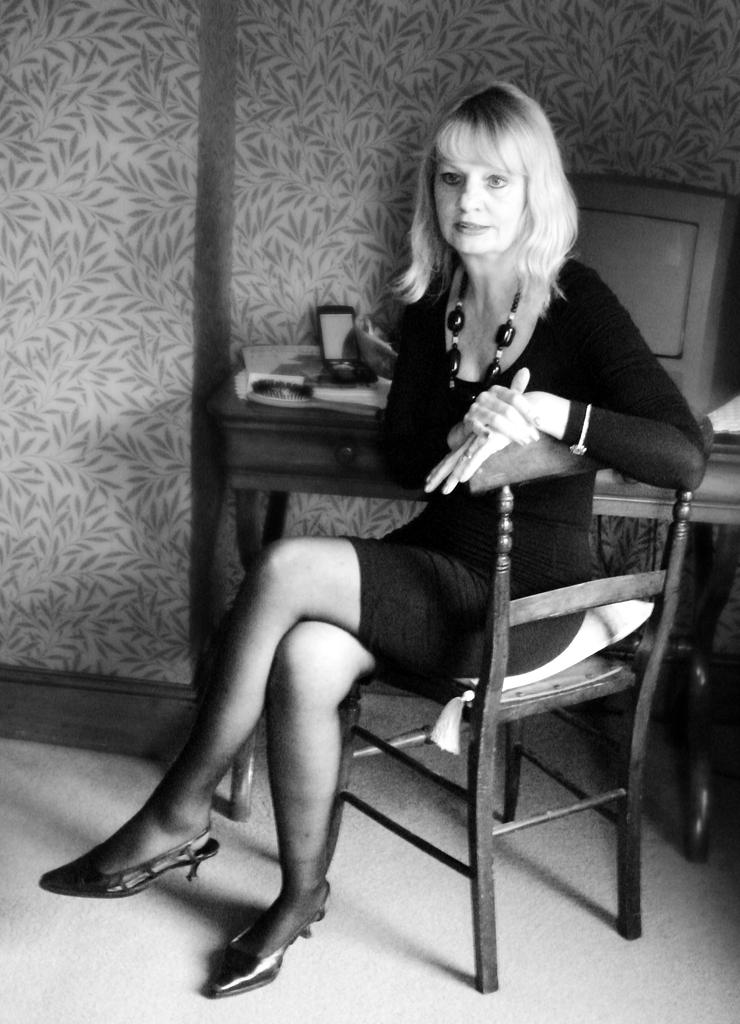What is the person in the image doing? The person is sitting on a chair in the image. What is located near the person? There is a table in the image. What can be seen on the table? There are objects on the table, including a system. What is visible in the background of the image? There is a wall visible in the image. What type of bait is being used to attract the fuel in the image? There is no bait or fuel present in the image. How does friction affect the system on the table in the image? The image does not provide information about friction or its effects on the system on the table. 